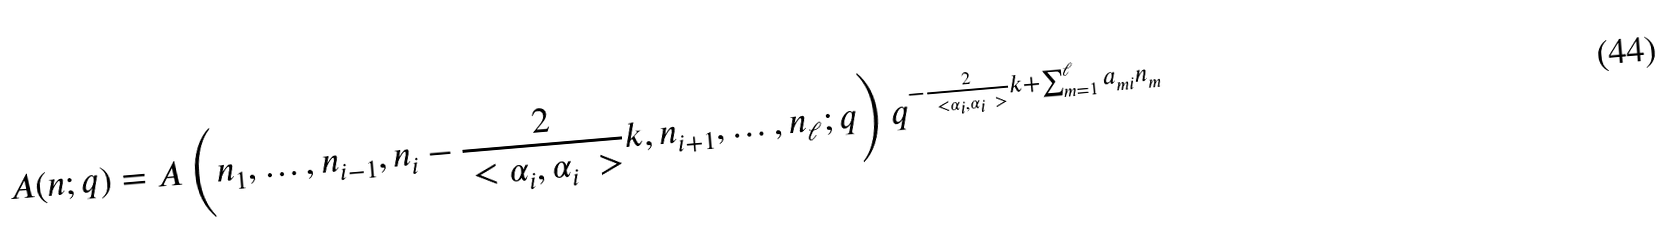Convert formula to latex. <formula><loc_0><loc_0><loc_500><loc_500>A ( n ; q ) = A \left ( n _ { 1 } , \dots , n _ { i - 1 } , n _ { i } - \frac { 2 } { \ < \alpha _ { i } , \alpha _ { i } \ > } k , n _ { i + 1 } , \dots , n _ { \ell } ; q \right ) q ^ { - \frac { 2 } { \ < \alpha _ { i } , \alpha _ { i } \ > } k + \sum _ { m = 1 } ^ { \ell } a _ { m i } n _ { m } }</formula> 